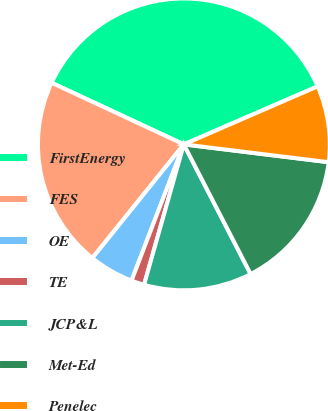Convert chart to OTSL. <chart><loc_0><loc_0><loc_500><loc_500><pie_chart><fcel>FirstEnergy<fcel>FES<fcel>OE<fcel>TE<fcel>JCP&L<fcel>Met-Ed<fcel>Penelec<nl><fcel>36.55%<fcel>21.16%<fcel>4.95%<fcel>1.44%<fcel>11.97%<fcel>15.48%<fcel>8.46%<nl></chart> 